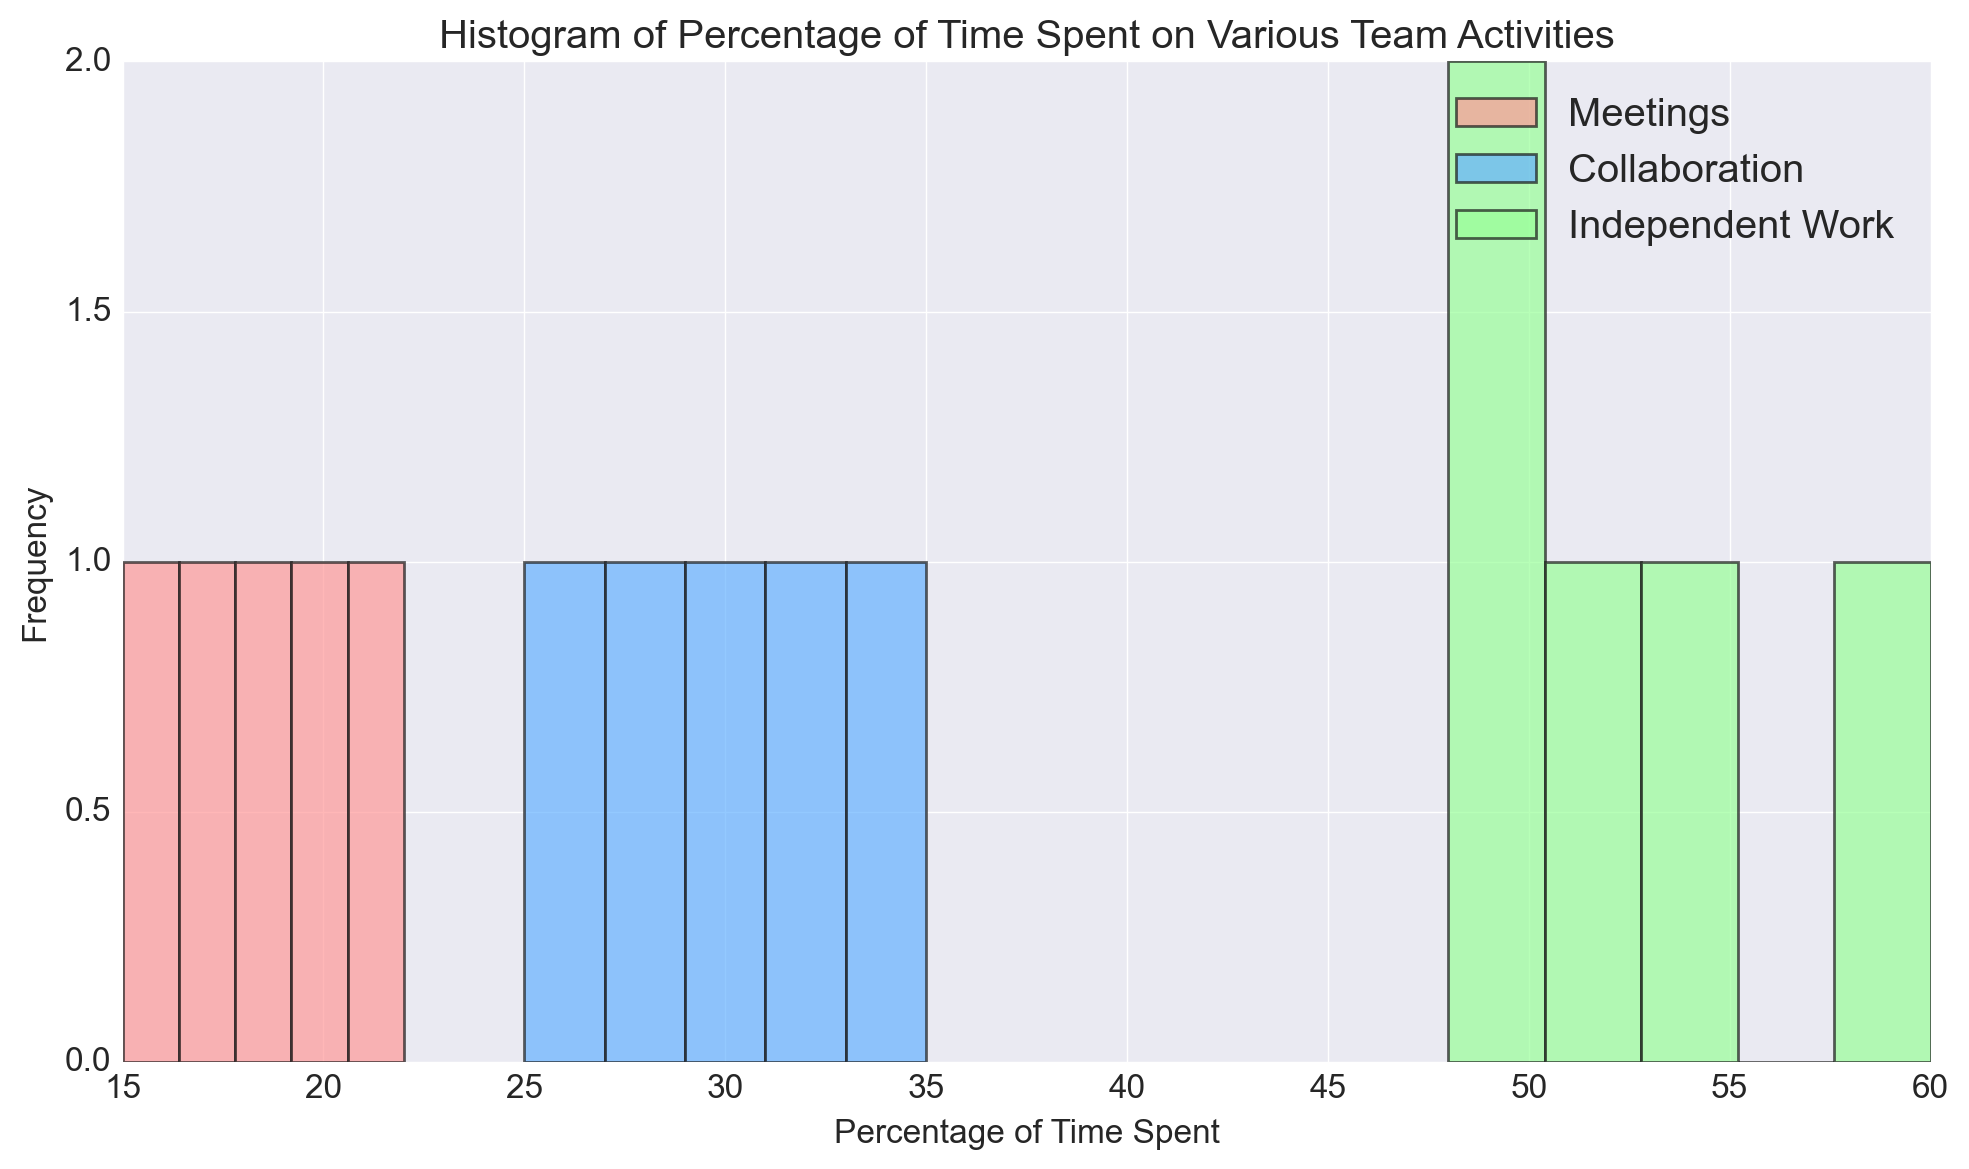How many activities are represented in the histogram? There are three distinct colors used in the histogram, each representing a different activity. By observing these, we can identify the three unique activities.
Answer: Three Which activity appears to have the highest maximum percentage value? Observing the histogram, Independent Work has the highest percentage bins, indicating its maximum value is higher than those of Meetings and Collaboration.
Answer: Independent Work What is the average percentage of time spent in Meetings? Sum the percentages for Meetings (15 + 20 + 18 + 22 + 17) to get 92. Divide by the number of data points (5) to find the average: 92 / 5 = 18.4.
Answer: 18.4 Compare the range of percentages between Collaboration and Independent Work. Which one is wider? The range for Collaboration is the difference between its highest (35) and lowest (25) values, which is 10. The range for Independent Work is the difference between its highest (60) and lowest (48) values, which is 12. Therefore, Independent Work has a wider range.
Answer: Independent Work Which activity's histogram appears to have the most tightly clustered data? By observing the spread of the bins on the histogram, Meetings appears to have the narrowest distribution, indicating its data points are more tightly clustered.
Answer: Meetings What's the median percentage of time spent on Collaboration? Arrange the percentages for Collaboration (25, 28, 30, 32, 35) in ascending order. The median value, being in the middle, is 30.
Answer: 30 For which activity is the distribution of percentages the most symmetric? Observing the shape of the histograms, Meetings appears the most symmetric about its central values compared to Collaboration and Independent Work.
Answer: Meetings Between Meetings and Collaboration, which has the higher median percentage of time spent? The median for Meetings is the middle value of (15, 17, 18, 20, 22), which is 18, while the median for Collaboration is 30. Hence, Collaboration has the higher median.
Answer: Collaboration Is the mode percentage of time spent on Independent Work greater or less than 50? By inspecting the histogram, we can see that the most frequent value (mode) for Independent Work is around 50 to 51. Thus, the mode is not greater than 50.
Answer: Less than 50 What is the range of percentages for the activity that involves the most teamwork? Collaboration would involve the most teamwork. The range is the difference between the highest (35) and lowest (25) values, which is 10.
Answer: 10 